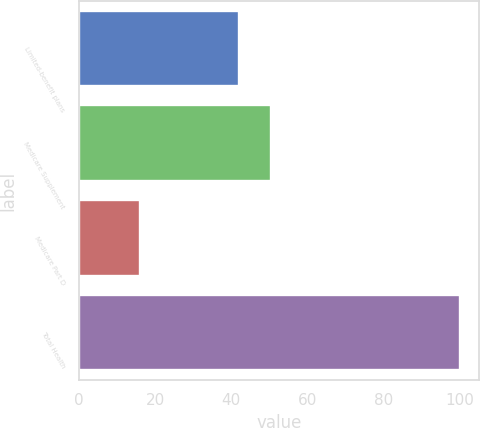<chart> <loc_0><loc_0><loc_500><loc_500><bar_chart><fcel>Limited-benefit plans<fcel>Medicare Supplement<fcel>Medicare Part D<fcel>Total Health<nl><fcel>42<fcel>50.4<fcel>16<fcel>100<nl></chart> 